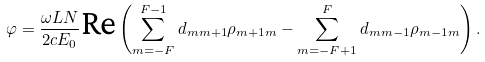<formula> <loc_0><loc_0><loc_500><loc_500>\varphi = \frac { \omega L N } { 2 c E _ { 0 } } \text {Re} \left ( \sum _ { m = - F } ^ { F - 1 } d _ { m m + 1 } \rho _ { m + 1 m } - \sum _ { m = - F + 1 } ^ { F } d _ { m m - 1 } \rho _ { m - 1 m } \right ) .</formula> 